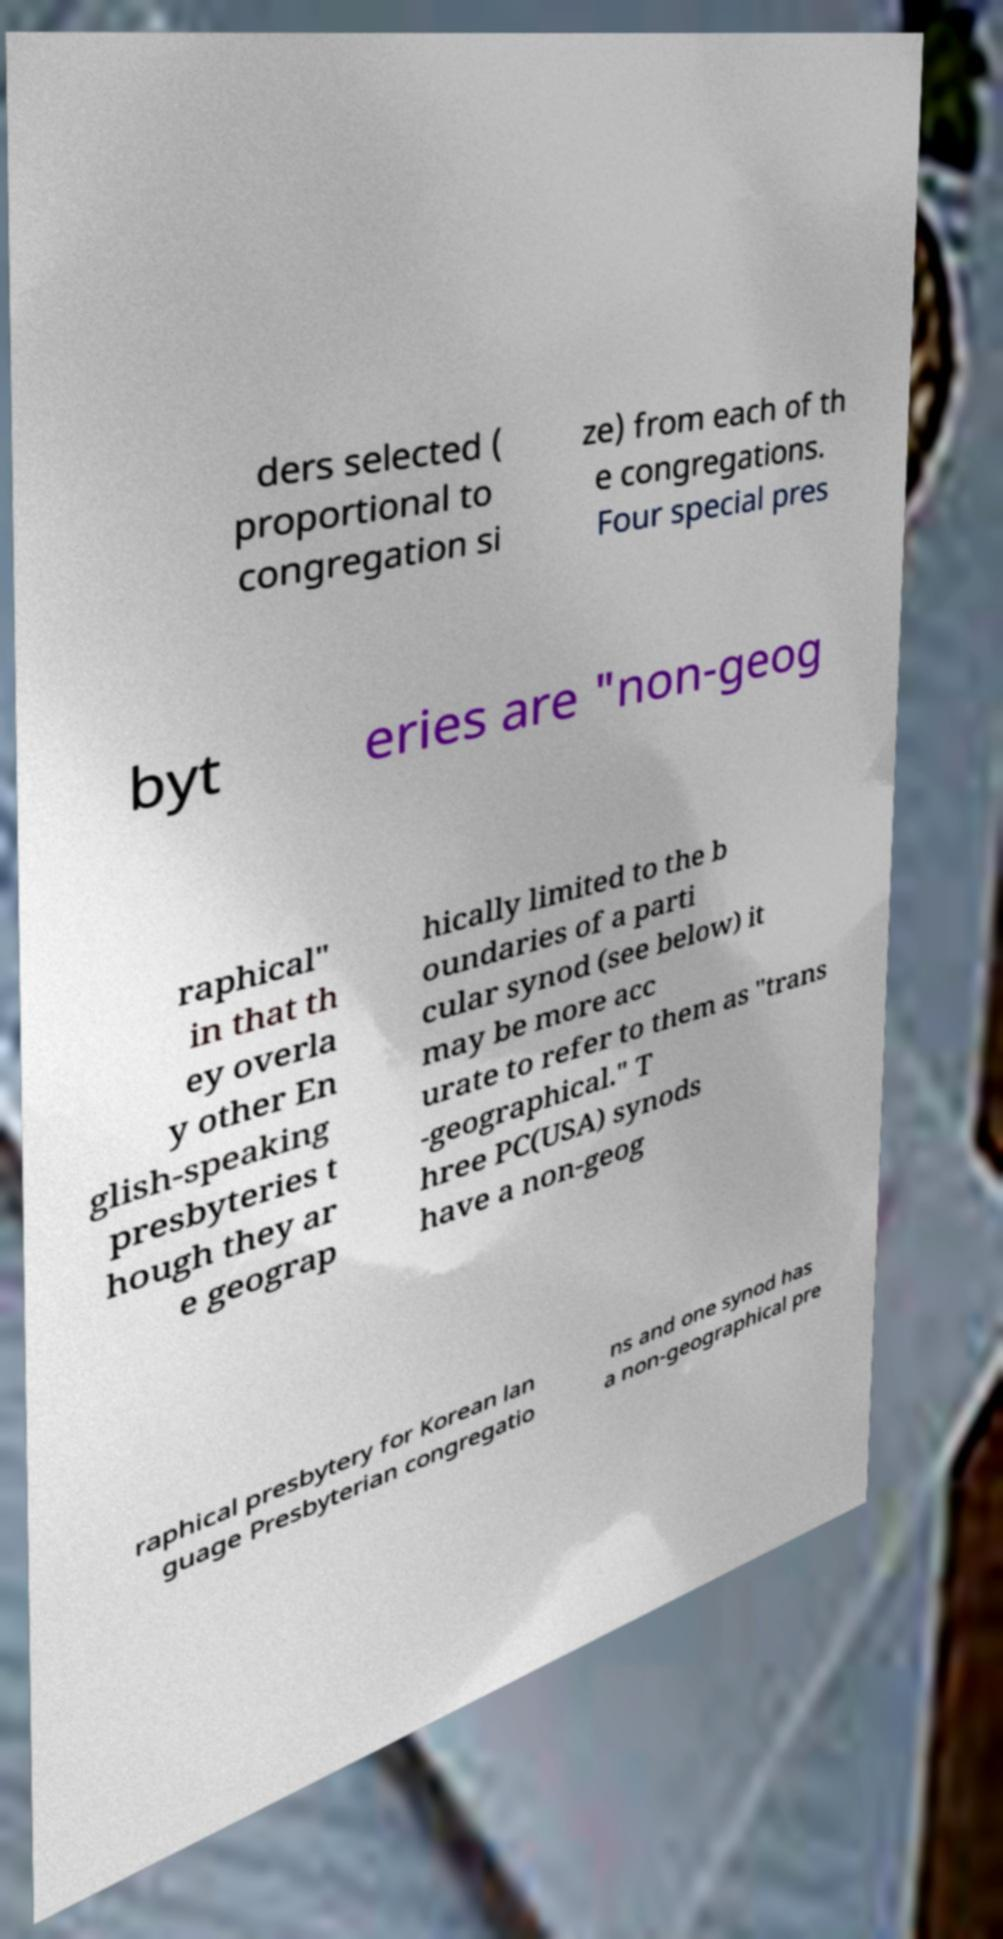Please read and relay the text visible in this image. What does it say? ders selected ( proportional to congregation si ze) from each of th e congregations. Four special pres byt eries are "non-geog raphical" in that th ey overla y other En glish-speaking presbyteries t hough they ar e geograp hically limited to the b oundaries of a parti cular synod (see below) it may be more acc urate to refer to them as "trans -geographical." T hree PC(USA) synods have a non-geog raphical presbytery for Korean lan guage Presbyterian congregatio ns and one synod has a non-geographical pre 